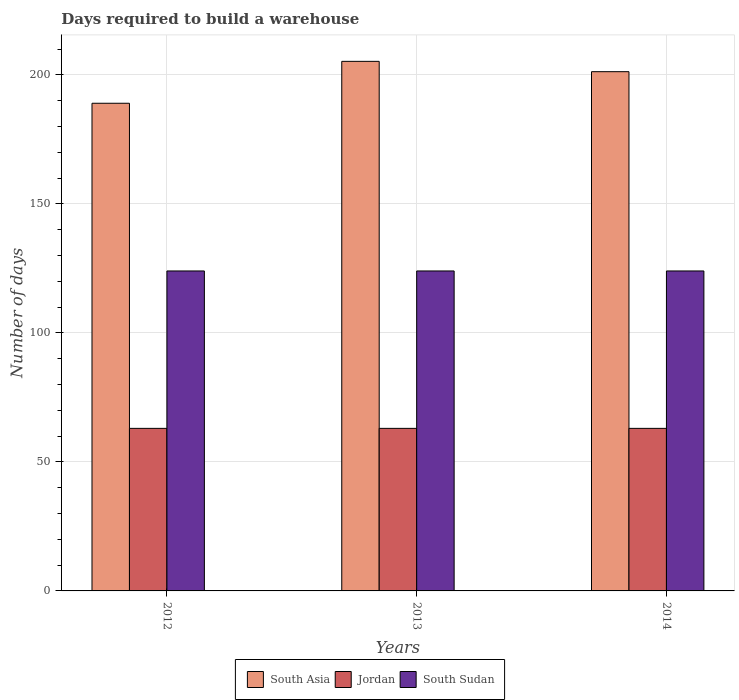How many groups of bars are there?
Your response must be concise. 3. How many bars are there on the 1st tick from the left?
Keep it short and to the point. 3. What is the label of the 3rd group of bars from the left?
Keep it short and to the point. 2014. What is the days required to build a warehouse in in Jordan in 2014?
Offer a very short reply. 63. Across all years, what is the maximum days required to build a warehouse in in South Sudan?
Your answer should be very brief. 124. Across all years, what is the minimum days required to build a warehouse in in South Asia?
Provide a succinct answer. 189. What is the total days required to build a warehouse in in South Sudan in the graph?
Make the answer very short. 372. What is the difference between the days required to build a warehouse in in Jordan in 2012 and that in 2013?
Offer a terse response. 0. What is the difference between the days required to build a warehouse in in South Asia in 2014 and the days required to build a warehouse in in Jordan in 2012?
Your response must be concise. 138.24. What is the average days required to build a warehouse in in Jordan per year?
Provide a short and direct response. 63. In the year 2012, what is the difference between the days required to build a warehouse in in South Sudan and days required to build a warehouse in in South Asia?
Your answer should be compact. -65. In how many years, is the days required to build a warehouse in in Jordan greater than 30 days?
Your response must be concise. 3. Is the difference between the days required to build a warehouse in in South Sudan in 2012 and 2014 greater than the difference between the days required to build a warehouse in in South Asia in 2012 and 2014?
Your answer should be compact. Yes. What is the difference between the highest and the second highest days required to build a warehouse in in South Asia?
Ensure brevity in your answer.  4. In how many years, is the days required to build a warehouse in in South Asia greater than the average days required to build a warehouse in in South Asia taken over all years?
Offer a terse response. 2. What does the 2nd bar from the left in 2013 represents?
Your answer should be compact. Jordan. What does the 1st bar from the right in 2014 represents?
Keep it short and to the point. South Sudan. How many bars are there?
Keep it short and to the point. 9. How many years are there in the graph?
Your answer should be compact. 3. Does the graph contain grids?
Provide a short and direct response. Yes. How many legend labels are there?
Your answer should be very brief. 3. What is the title of the graph?
Make the answer very short. Days required to build a warehouse. What is the label or title of the X-axis?
Provide a short and direct response. Years. What is the label or title of the Y-axis?
Your response must be concise. Number of days. What is the Number of days of South Asia in 2012?
Give a very brief answer. 189. What is the Number of days of Jordan in 2012?
Offer a terse response. 63. What is the Number of days of South Sudan in 2012?
Keep it short and to the point. 124. What is the Number of days of South Asia in 2013?
Keep it short and to the point. 205.24. What is the Number of days in Jordan in 2013?
Give a very brief answer. 63. What is the Number of days of South Sudan in 2013?
Ensure brevity in your answer.  124. What is the Number of days in South Asia in 2014?
Your answer should be very brief. 201.24. What is the Number of days of South Sudan in 2014?
Make the answer very short. 124. Across all years, what is the maximum Number of days in South Asia?
Your response must be concise. 205.24. Across all years, what is the maximum Number of days of Jordan?
Offer a very short reply. 63. Across all years, what is the maximum Number of days in South Sudan?
Offer a very short reply. 124. Across all years, what is the minimum Number of days of South Asia?
Offer a terse response. 189. Across all years, what is the minimum Number of days in Jordan?
Provide a short and direct response. 63. Across all years, what is the minimum Number of days in South Sudan?
Keep it short and to the point. 124. What is the total Number of days in South Asia in the graph?
Your answer should be very brief. 595.48. What is the total Number of days in Jordan in the graph?
Make the answer very short. 189. What is the total Number of days of South Sudan in the graph?
Give a very brief answer. 372. What is the difference between the Number of days in South Asia in 2012 and that in 2013?
Your answer should be very brief. -16.24. What is the difference between the Number of days in South Asia in 2012 and that in 2014?
Offer a terse response. -12.24. What is the difference between the Number of days of South Sudan in 2012 and that in 2014?
Keep it short and to the point. 0. What is the difference between the Number of days of Jordan in 2013 and that in 2014?
Keep it short and to the point. 0. What is the difference between the Number of days in South Sudan in 2013 and that in 2014?
Provide a short and direct response. 0. What is the difference between the Number of days of South Asia in 2012 and the Number of days of Jordan in 2013?
Ensure brevity in your answer.  126. What is the difference between the Number of days in Jordan in 2012 and the Number of days in South Sudan in 2013?
Your answer should be very brief. -61. What is the difference between the Number of days of South Asia in 2012 and the Number of days of Jordan in 2014?
Ensure brevity in your answer.  126. What is the difference between the Number of days in Jordan in 2012 and the Number of days in South Sudan in 2014?
Provide a short and direct response. -61. What is the difference between the Number of days in South Asia in 2013 and the Number of days in Jordan in 2014?
Your answer should be very brief. 142.24. What is the difference between the Number of days of South Asia in 2013 and the Number of days of South Sudan in 2014?
Give a very brief answer. 81.24. What is the difference between the Number of days in Jordan in 2013 and the Number of days in South Sudan in 2014?
Ensure brevity in your answer.  -61. What is the average Number of days in South Asia per year?
Make the answer very short. 198.49. What is the average Number of days of South Sudan per year?
Your response must be concise. 124. In the year 2012, what is the difference between the Number of days of South Asia and Number of days of Jordan?
Ensure brevity in your answer.  126. In the year 2012, what is the difference between the Number of days of Jordan and Number of days of South Sudan?
Ensure brevity in your answer.  -61. In the year 2013, what is the difference between the Number of days of South Asia and Number of days of Jordan?
Your response must be concise. 142.24. In the year 2013, what is the difference between the Number of days of South Asia and Number of days of South Sudan?
Provide a short and direct response. 81.24. In the year 2013, what is the difference between the Number of days of Jordan and Number of days of South Sudan?
Keep it short and to the point. -61. In the year 2014, what is the difference between the Number of days in South Asia and Number of days in Jordan?
Provide a short and direct response. 138.24. In the year 2014, what is the difference between the Number of days in South Asia and Number of days in South Sudan?
Offer a terse response. 77.24. In the year 2014, what is the difference between the Number of days of Jordan and Number of days of South Sudan?
Your answer should be compact. -61. What is the ratio of the Number of days of South Asia in 2012 to that in 2013?
Provide a succinct answer. 0.92. What is the ratio of the Number of days in Jordan in 2012 to that in 2013?
Offer a very short reply. 1. What is the ratio of the Number of days in South Asia in 2012 to that in 2014?
Your response must be concise. 0.94. What is the ratio of the Number of days of Jordan in 2012 to that in 2014?
Your response must be concise. 1. What is the ratio of the Number of days in South Asia in 2013 to that in 2014?
Your response must be concise. 1.02. What is the ratio of the Number of days of South Sudan in 2013 to that in 2014?
Provide a short and direct response. 1. What is the difference between the highest and the second highest Number of days in Jordan?
Offer a very short reply. 0. What is the difference between the highest and the second highest Number of days in South Sudan?
Your response must be concise. 0. What is the difference between the highest and the lowest Number of days of South Asia?
Make the answer very short. 16.24. 